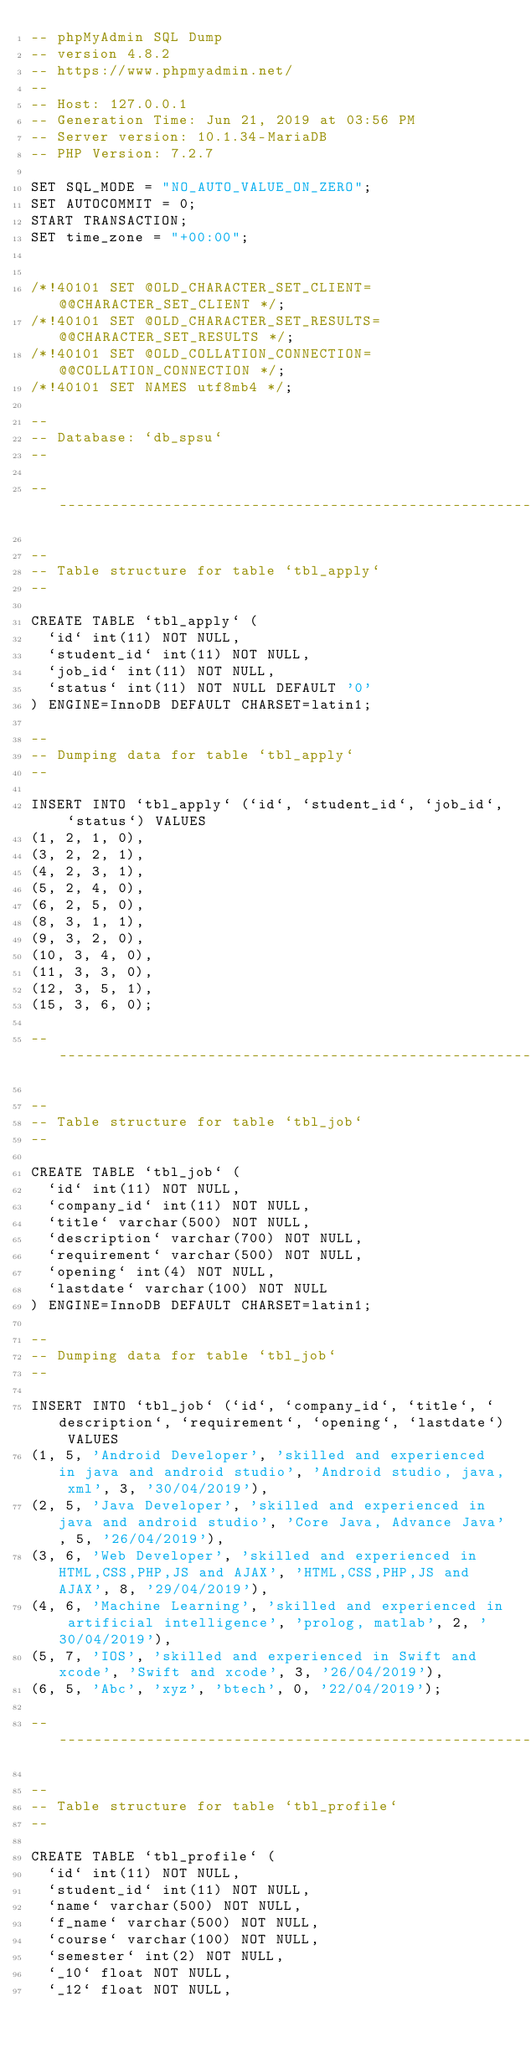Convert code to text. <code><loc_0><loc_0><loc_500><loc_500><_SQL_>-- phpMyAdmin SQL Dump
-- version 4.8.2
-- https://www.phpmyadmin.net/
--
-- Host: 127.0.0.1
-- Generation Time: Jun 21, 2019 at 03:56 PM
-- Server version: 10.1.34-MariaDB
-- PHP Version: 7.2.7

SET SQL_MODE = "NO_AUTO_VALUE_ON_ZERO";
SET AUTOCOMMIT = 0;
START TRANSACTION;
SET time_zone = "+00:00";


/*!40101 SET @OLD_CHARACTER_SET_CLIENT=@@CHARACTER_SET_CLIENT */;
/*!40101 SET @OLD_CHARACTER_SET_RESULTS=@@CHARACTER_SET_RESULTS */;
/*!40101 SET @OLD_COLLATION_CONNECTION=@@COLLATION_CONNECTION */;
/*!40101 SET NAMES utf8mb4 */;

--
-- Database: `db_spsu`
--

-- --------------------------------------------------------

--
-- Table structure for table `tbl_apply`
--

CREATE TABLE `tbl_apply` (
  `id` int(11) NOT NULL,
  `student_id` int(11) NOT NULL,
  `job_id` int(11) NOT NULL,
  `status` int(11) NOT NULL DEFAULT '0'
) ENGINE=InnoDB DEFAULT CHARSET=latin1;

--
-- Dumping data for table `tbl_apply`
--

INSERT INTO `tbl_apply` (`id`, `student_id`, `job_id`, `status`) VALUES
(1, 2, 1, 0),
(3, 2, 2, 1),
(4, 2, 3, 1),
(5, 2, 4, 0),
(6, 2, 5, 0),
(8, 3, 1, 1),
(9, 3, 2, 0),
(10, 3, 4, 0),
(11, 3, 3, 0),
(12, 3, 5, 1),
(15, 3, 6, 0);

-- --------------------------------------------------------

--
-- Table structure for table `tbl_job`
--

CREATE TABLE `tbl_job` (
  `id` int(11) NOT NULL,
  `company_id` int(11) NOT NULL,
  `title` varchar(500) NOT NULL,
  `description` varchar(700) NOT NULL,
  `requirement` varchar(500) NOT NULL,
  `opening` int(4) NOT NULL,
  `lastdate` varchar(100) NOT NULL
) ENGINE=InnoDB DEFAULT CHARSET=latin1;

--
-- Dumping data for table `tbl_job`
--

INSERT INTO `tbl_job` (`id`, `company_id`, `title`, `description`, `requirement`, `opening`, `lastdate`) VALUES
(1, 5, 'Android Developer', 'skilled and experienced in java and android studio', 'Android studio, java, xml', 3, '30/04/2019'),
(2, 5, 'Java Developer', 'skilled and experienced in java and android studio', 'Core Java, Advance Java', 5, '26/04/2019'),
(3, 6, 'Web Developer', 'skilled and experienced in HTML,CSS,PHP,JS and AJAX', 'HTML,CSS,PHP,JS and AJAX', 8, '29/04/2019'),
(4, 6, 'Machine Learning', 'skilled and experienced in artificial intelligence', 'prolog, matlab', 2, '30/04/2019'),
(5, 7, 'IOS', 'skilled and experienced in Swift and xcode', 'Swift and xcode', 3, '26/04/2019'),
(6, 5, 'Abc', 'xyz', 'btech', 0, '22/04/2019');

-- --------------------------------------------------------

--
-- Table structure for table `tbl_profile`
--

CREATE TABLE `tbl_profile` (
  `id` int(11) NOT NULL,
  `student_id` int(11) NOT NULL,
  `name` varchar(500) NOT NULL,
  `f_name` varchar(500) NOT NULL,
  `course` varchar(100) NOT NULL,
  `semester` int(2) NOT NULL,
  `_10` float NOT NULL,
  `_12` float NOT NULL,</code> 